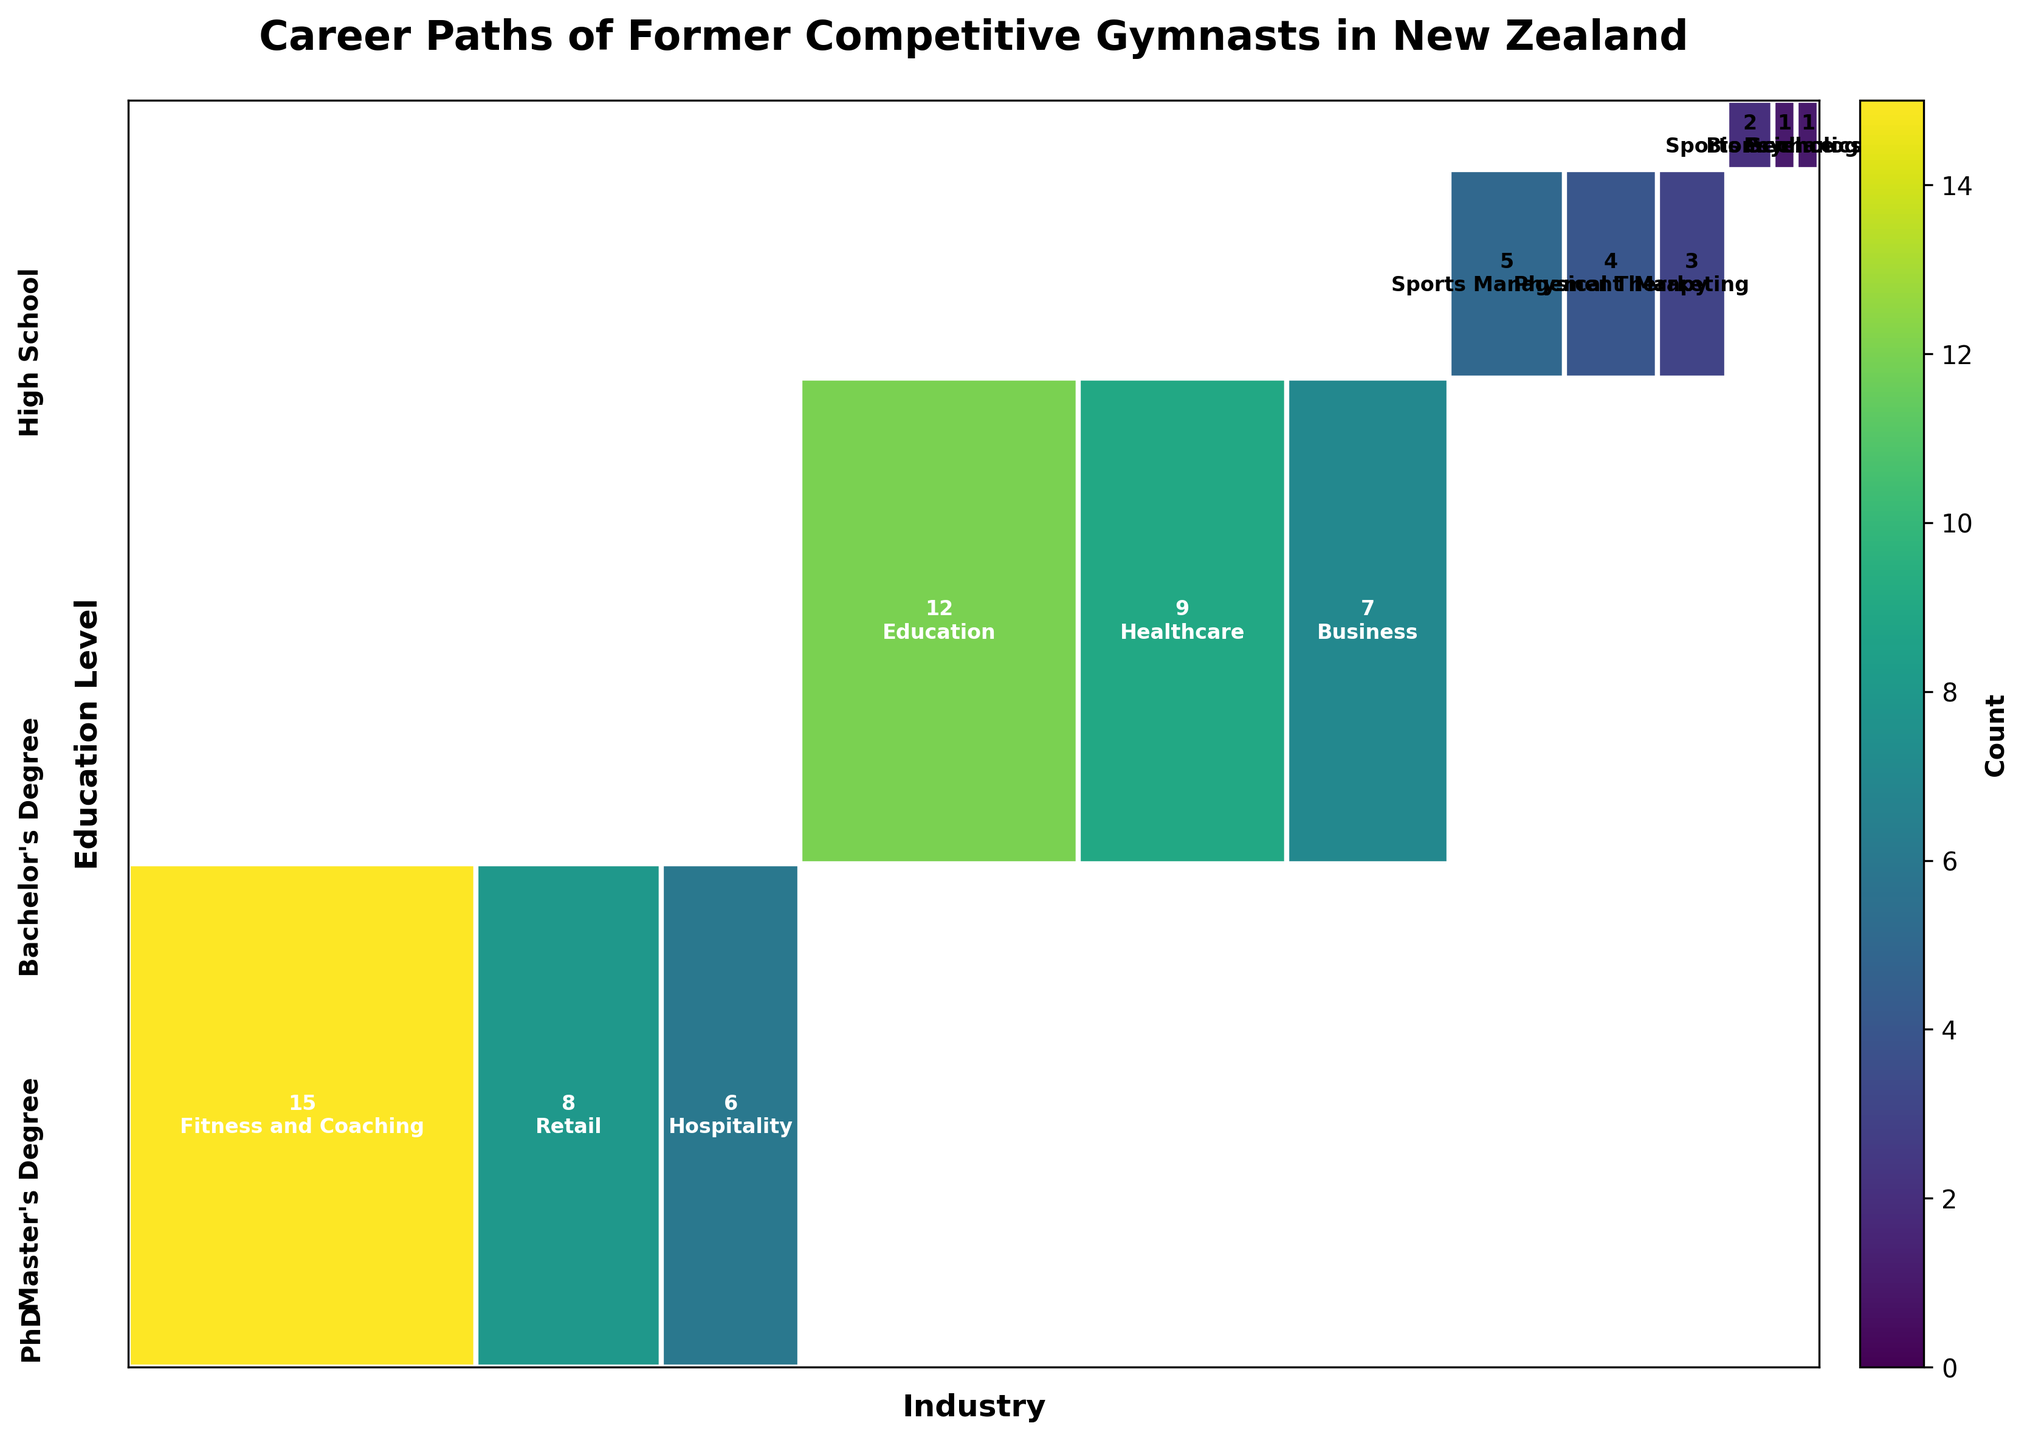What's the title of the plot? The title is prominently displayed at the top of the plot. It summarises the main subject of the visualization.
Answer: Career Paths of Former Competitive Gymnasts in New Zealand Which education level has the highest overall count in career paths? By observing the size of the rectangles, the largest section belongs to those with a Bachelor's Degree, indicated by more area occupied collectively by careers within this education level.
Answer: Bachelor's Degree How many former gymnasts with a PhD are in Sports Science? Find the intersection of PhD and Sports Science sectors, which has a count displayed within the respective rectangle.
Answer: 2 Compare the number of gymnasts with a High School education level working in Fitness and Coaching to those working in Hospitality. Which is higher? Locate the rectangles representing High School in both Fitness and Coaching, and Hospitality. The count within the Fitness and Coaching rectangle is higher than that within the Hospitality rectangle.
Answer: Fitness and Coaching What's the sum of former gymnasts with a Master's Degree in Sports Management and Marketing? Identify and sum the counts in the Sports Management and Marketing rectangles within the Master's Degree section. Sports Management has 5, and Marketing has 3, summing to 8.
Answer: 8 Which industry has the highest representation of gymnasts with a Bachelor's Degree? Within the Bachelor's Degree section, the largest rectangle corresponds to Education.
Answer: Education How does the number of gymnasts with a high school education working in Retail compare to those in Hospitality? Compare the counts in the Retail and Hospitality sectors within the High School section. Retail (8) is higher than Hospitality (6).
Answer: Retail What is the combined number of gymnasts with a Master's Degree or PhD working in physical therapy? Sum the counts for Physical Therapy in the Master's Degree section (4) and check the PhD section (none listed in Physical Therapy).
Answer: 4 Which education level has the smallest overall count in career paths? The PhD education level has the smallest section area, indicating the least count across all industries.
Answer: PhD What's the total number of gymnasts with a Bachelor's Degree working in Business, Healthcare, and Education? Sum the counts in the Business (7), Healthcare (9), and Education (12) categories within the Bachelor's Degree section. 7 + 9 + 12 = 28.
Answer: 28 